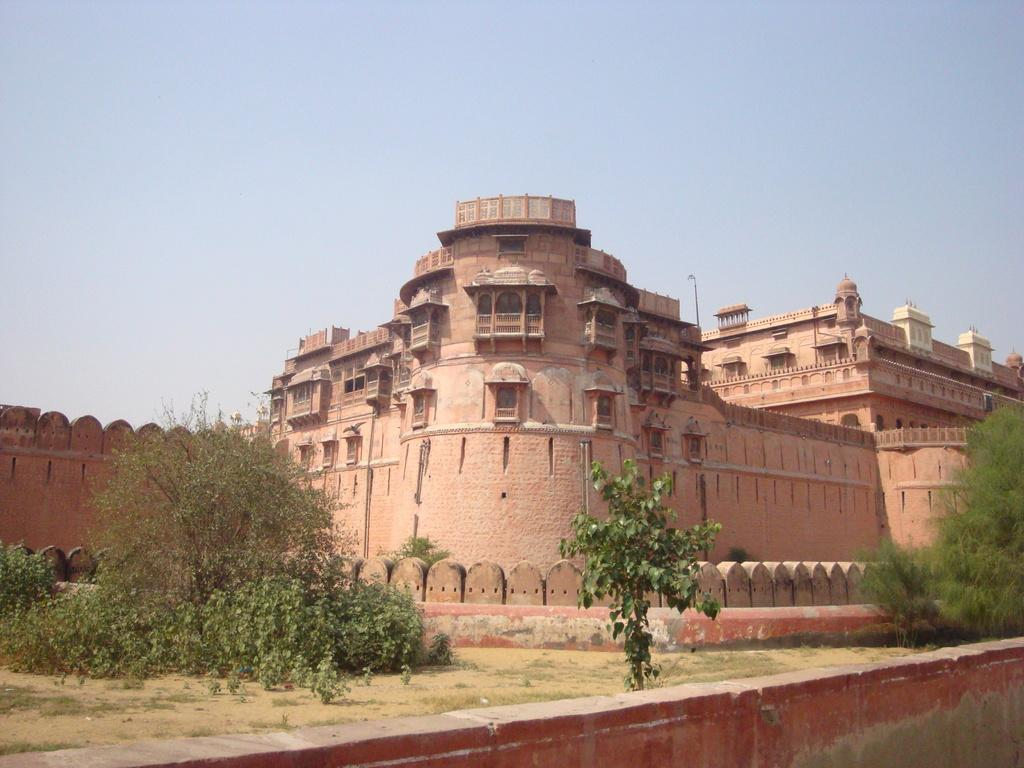What is located in the front of the image? There are plants and a wall in the front of the image. What can be seen in the background of the image? There is a building and the sky visible in the background of the image. How much sugar is present in the image? There is no sugar present in the image. What type of heat source can be seen in the image? There is no heat source visible in the image. 